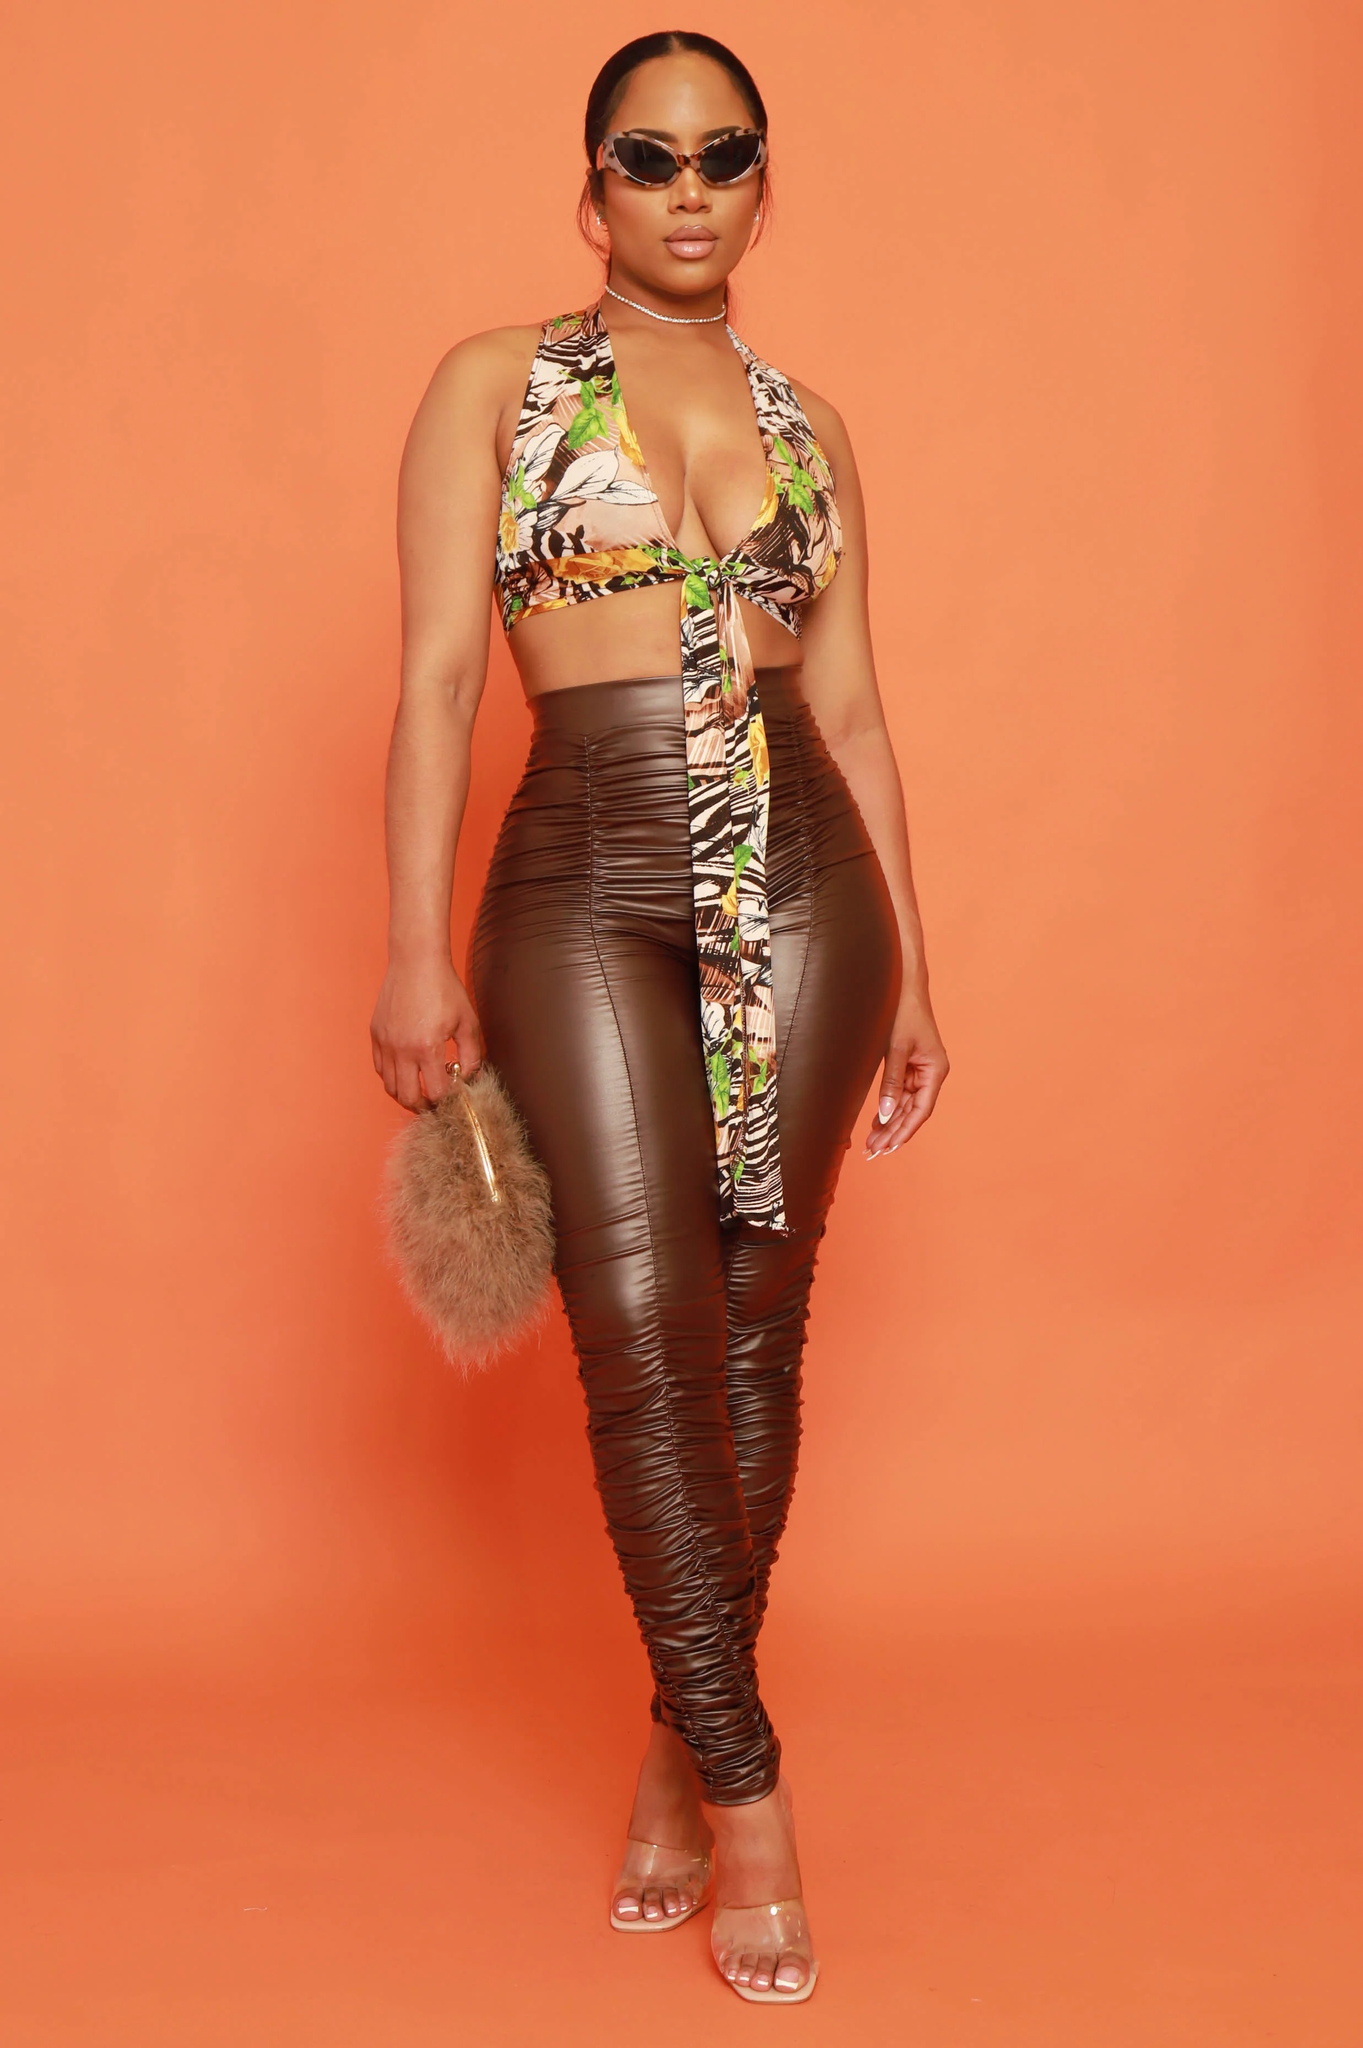List the individual pieces of clothing worn by the woman.  The woman in the image is wearing:

1. A halter neck crop top with a tropical print.
2. High-waisted ruched leggings in a shiny, possibly faux leather material.
3. Clear strap high-heeled sandals.

She is also accessorized with:

1. Sunglasses with a sleek design.
2. A choker necklace.
3. A furry clutch or handbag. 